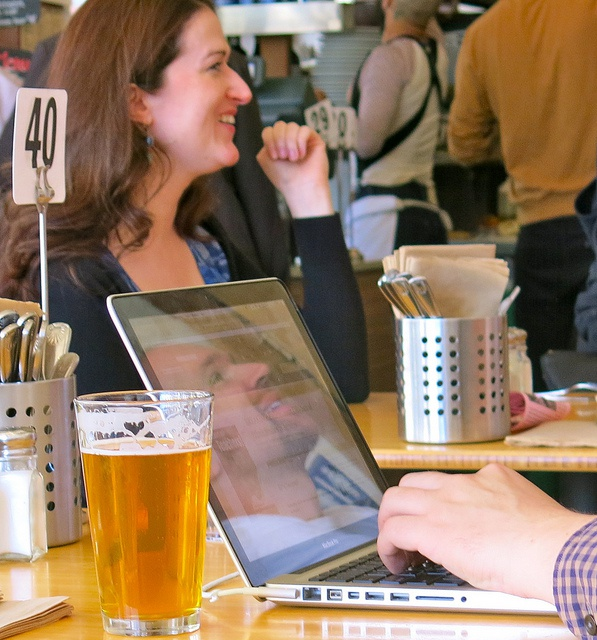Describe the objects in this image and their specific colors. I can see people in gray, black, maroon, and lightpink tones, laptop in gray, darkgray, and tan tones, dining table in gray, orange, and white tones, dining table in gray, white, and tan tones, and people in gray, olive, black, and maroon tones in this image. 